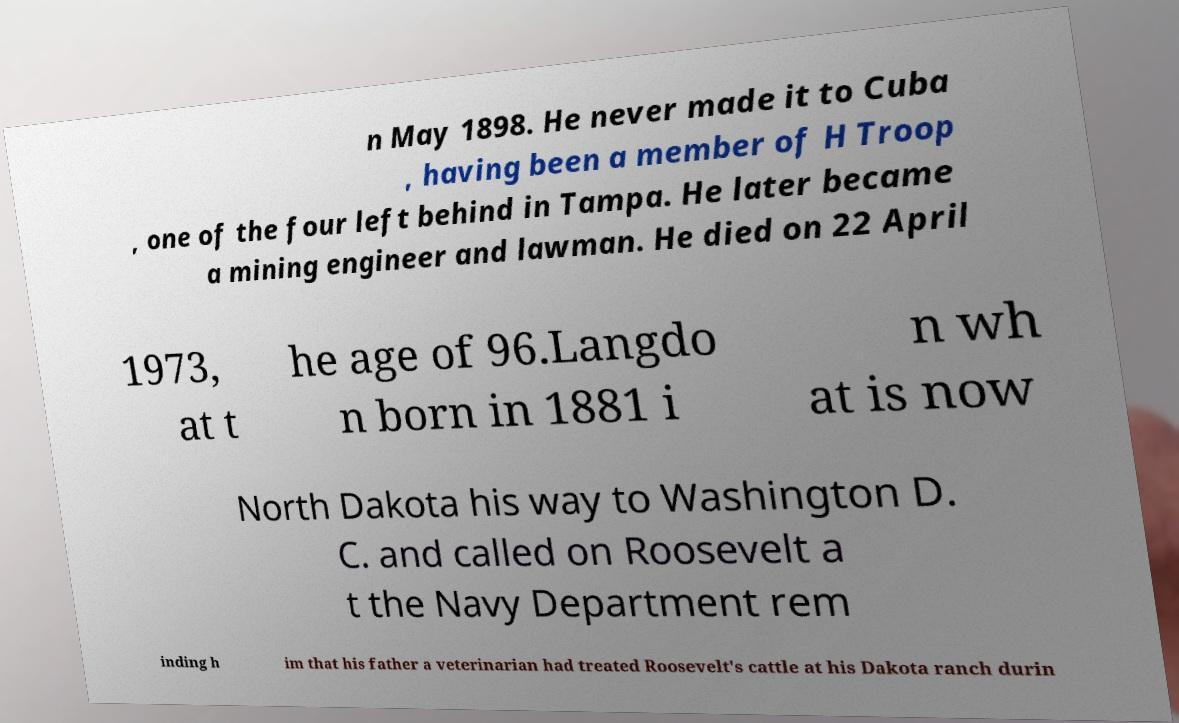I need the written content from this picture converted into text. Can you do that? n May 1898. He never made it to Cuba , having been a member of H Troop , one of the four left behind in Tampa. He later became a mining engineer and lawman. He died on 22 April 1973, at t he age of 96.Langdo n born in 1881 i n wh at is now North Dakota his way to Washington D. C. and called on Roosevelt a t the Navy Department rem inding h im that his father a veterinarian had treated Roosevelt's cattle at his Dakota ranch durin 